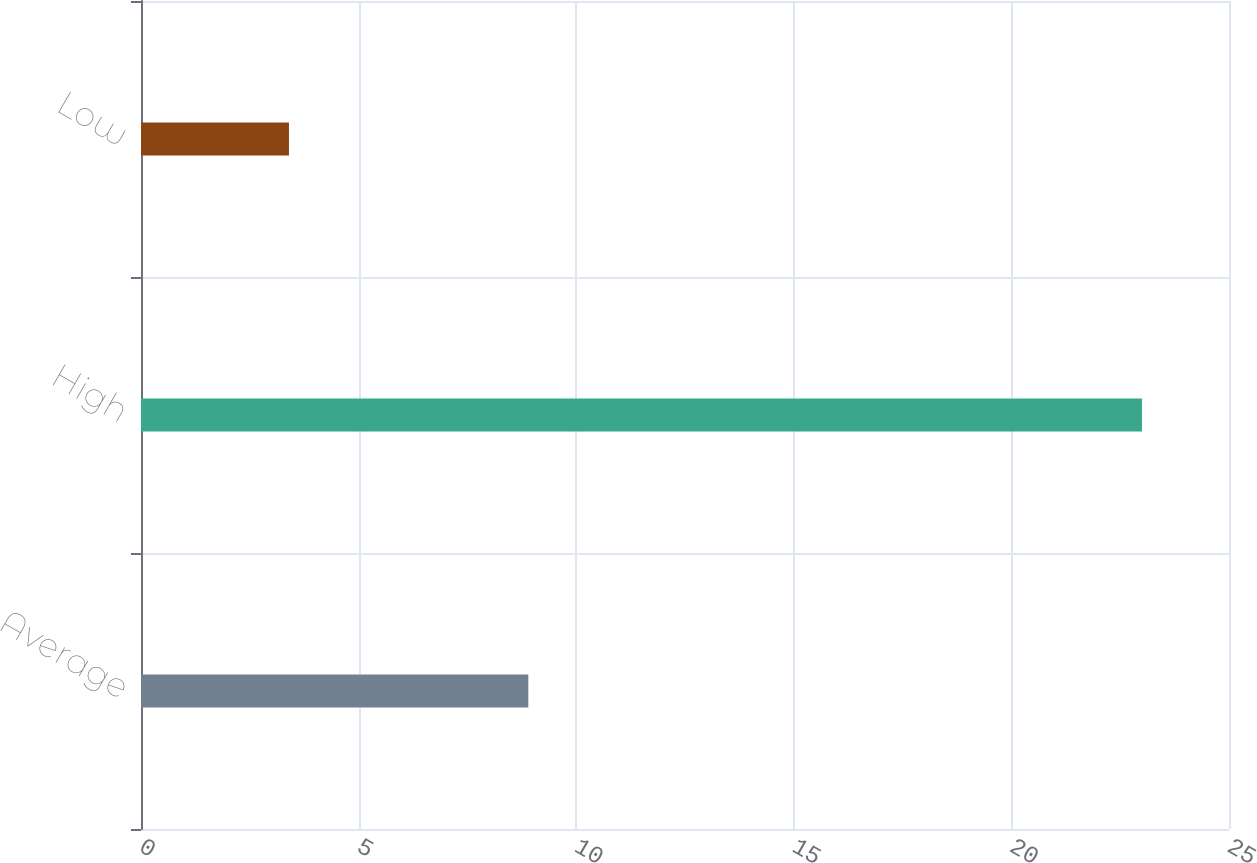Convert chart to OTSL. <chart><loc_0><loc_0><loc_500><loc_500><bar_chart><fcel>Average<fcel>High<fcel>Low<nl><fcel>8.9<fcel>23<fcel>3.4<nl></chart> 